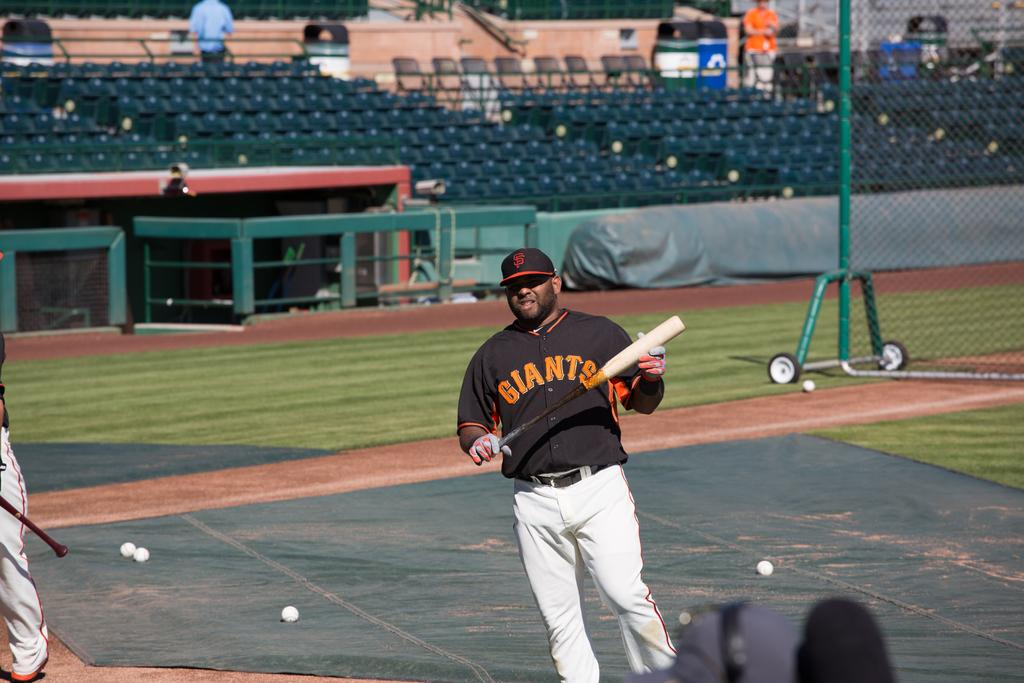Provide a one-sentence caption for the provided image. a giants baseball player holding a black and white bat. 